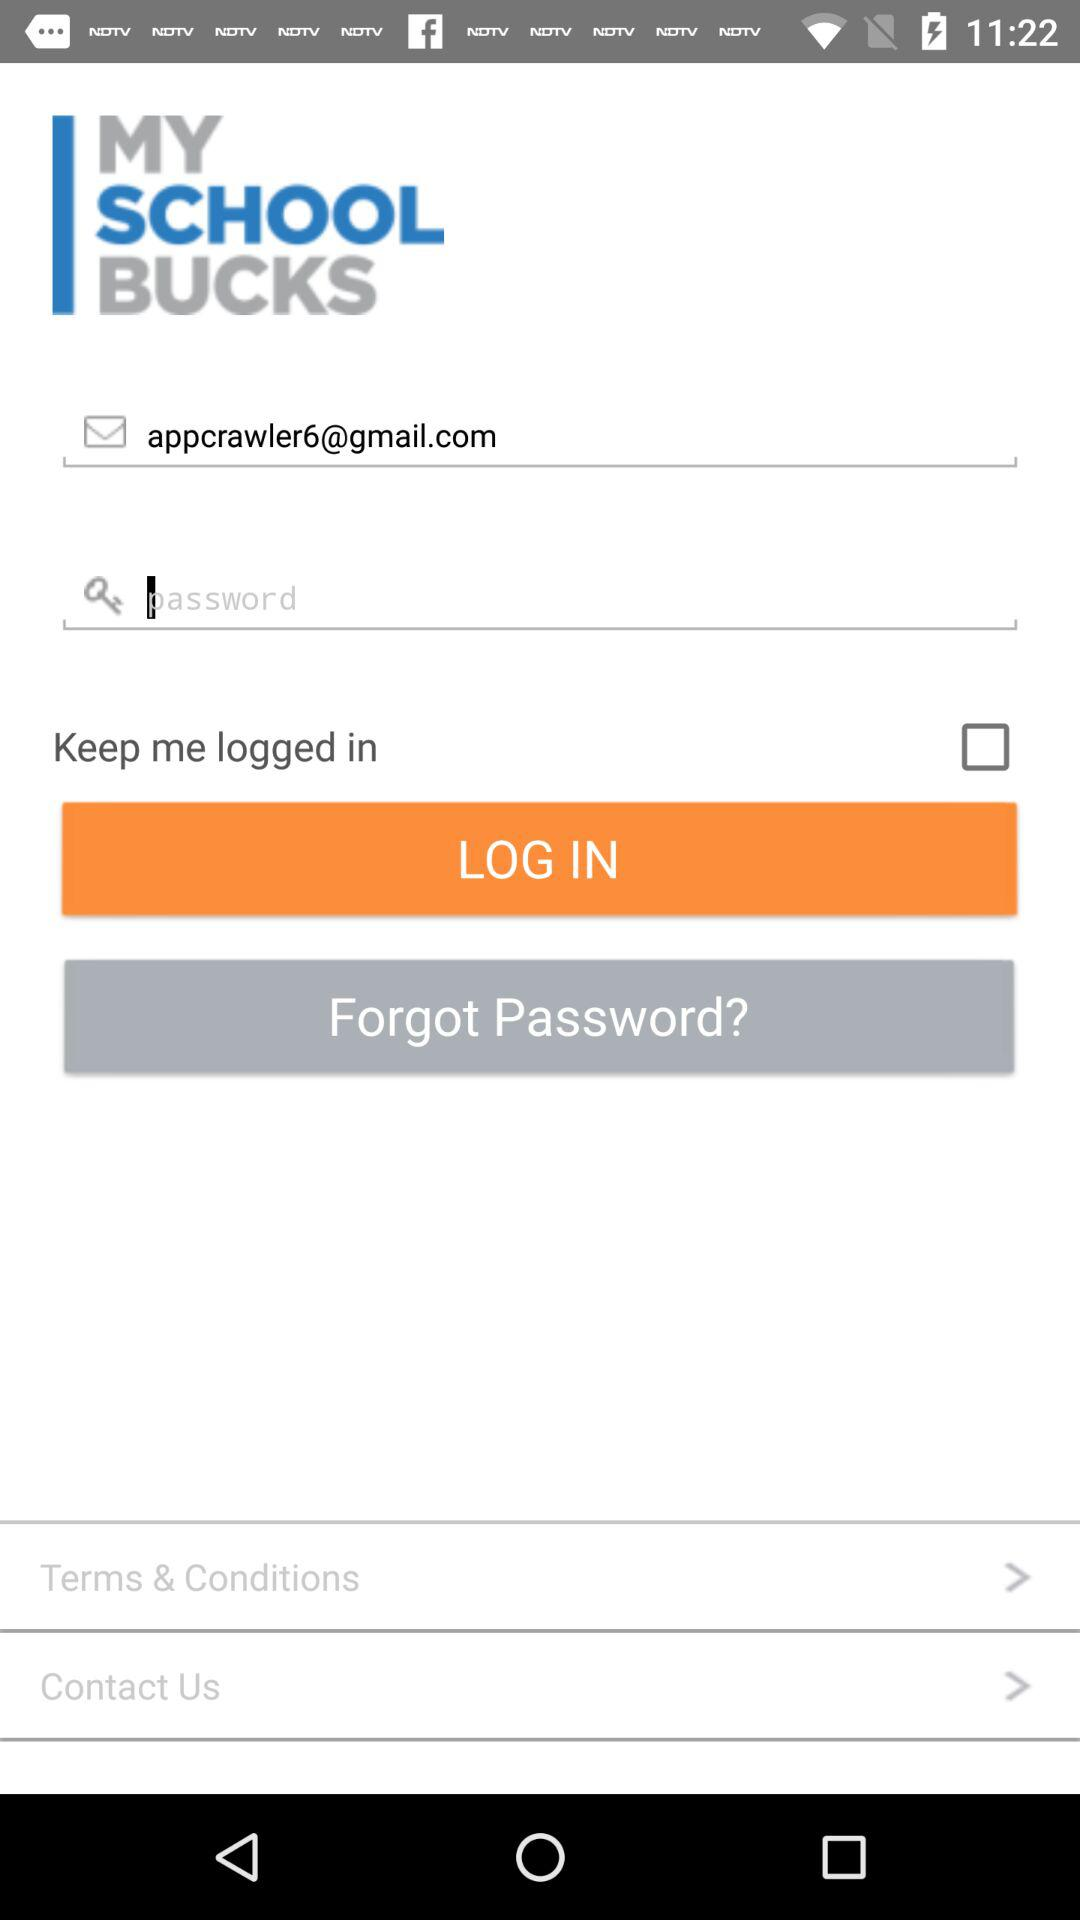What is the email address? The email address is appcrawler6@gmail.com. 